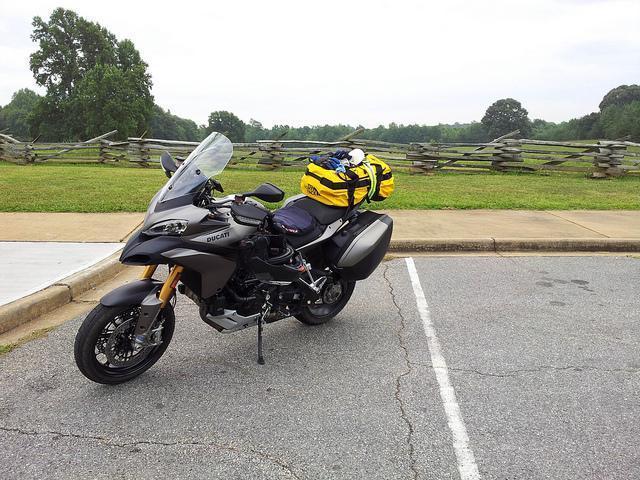How many people are sitting down in the image?
Give a very brief answer. 0. 